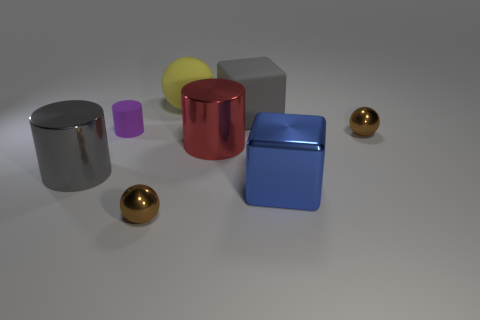Subtract all small brown metal spheres. How many spheres are left? 1 Subtract all red cylinders. How many cylinders are left? 2 Subtract 2 cylinders. How many cylinders are left? 1 Add 2 big balls. How many objects exist? 10 Subtract all yellow spheres. How many gray cubes are left? 1 Subtract all yellow rubber balls. Subtract all purple cylinders. How many objects are left? 6 Add 5 small brown objects. How many small brown objects are left? 7 Add 5 tiny brown cylinders. How many tiny brown cylinders exist? 5 Subtract 0 cyan cylinders. How many objects are left? 8 Subtract all balls. How many objects are left? 5 